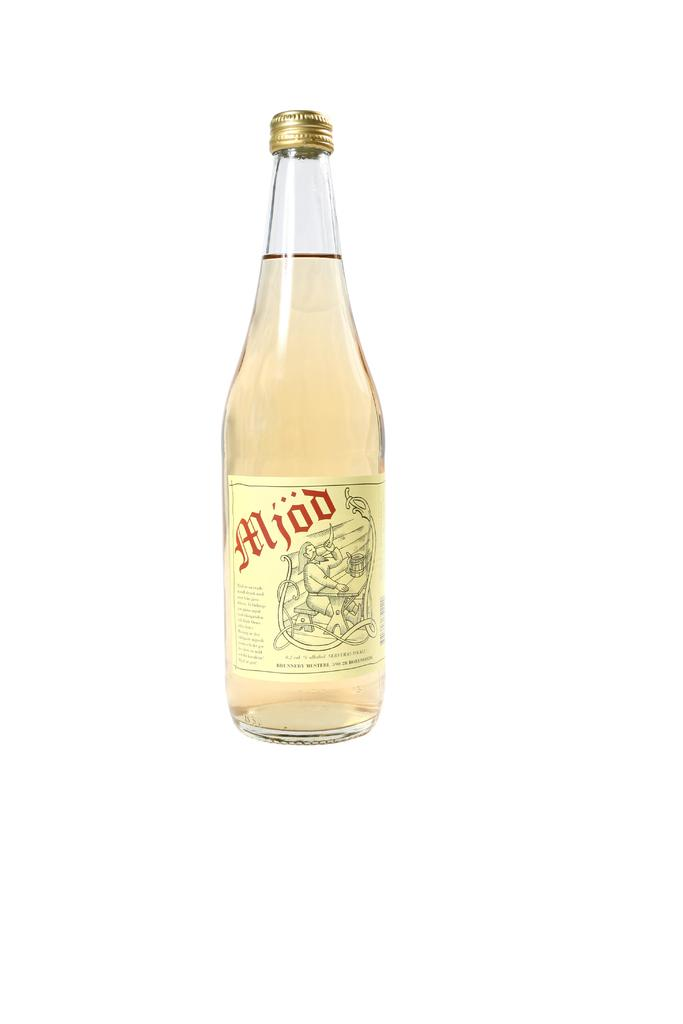Provide a one-sentence caption for the provided image. A bottle of light yellow Mjod with the cap closed. 